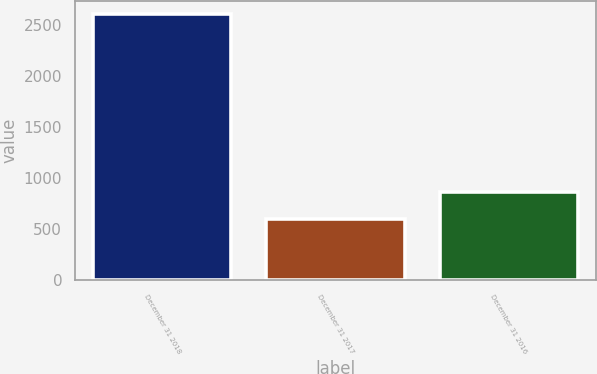Convert chart to OTSL. <chart><loc_0><loc_0><loc_500><loc_500><bar_chart><fcel>December 31 2018<fcel>December 31 2017<fcel>December 31 2016<nl><fcel>2601<fcel>596<fcel>862<nl></chart> 